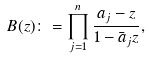Convert formula to latex. <formula><loc_0><loc_0><loc_500><loc_500>B ( z ) \colon = \prod _ { j = 1 } ^ { n } \frac { a _ { j } - z } { 1 - \bar { a } _ { j } z } ,</formula> 